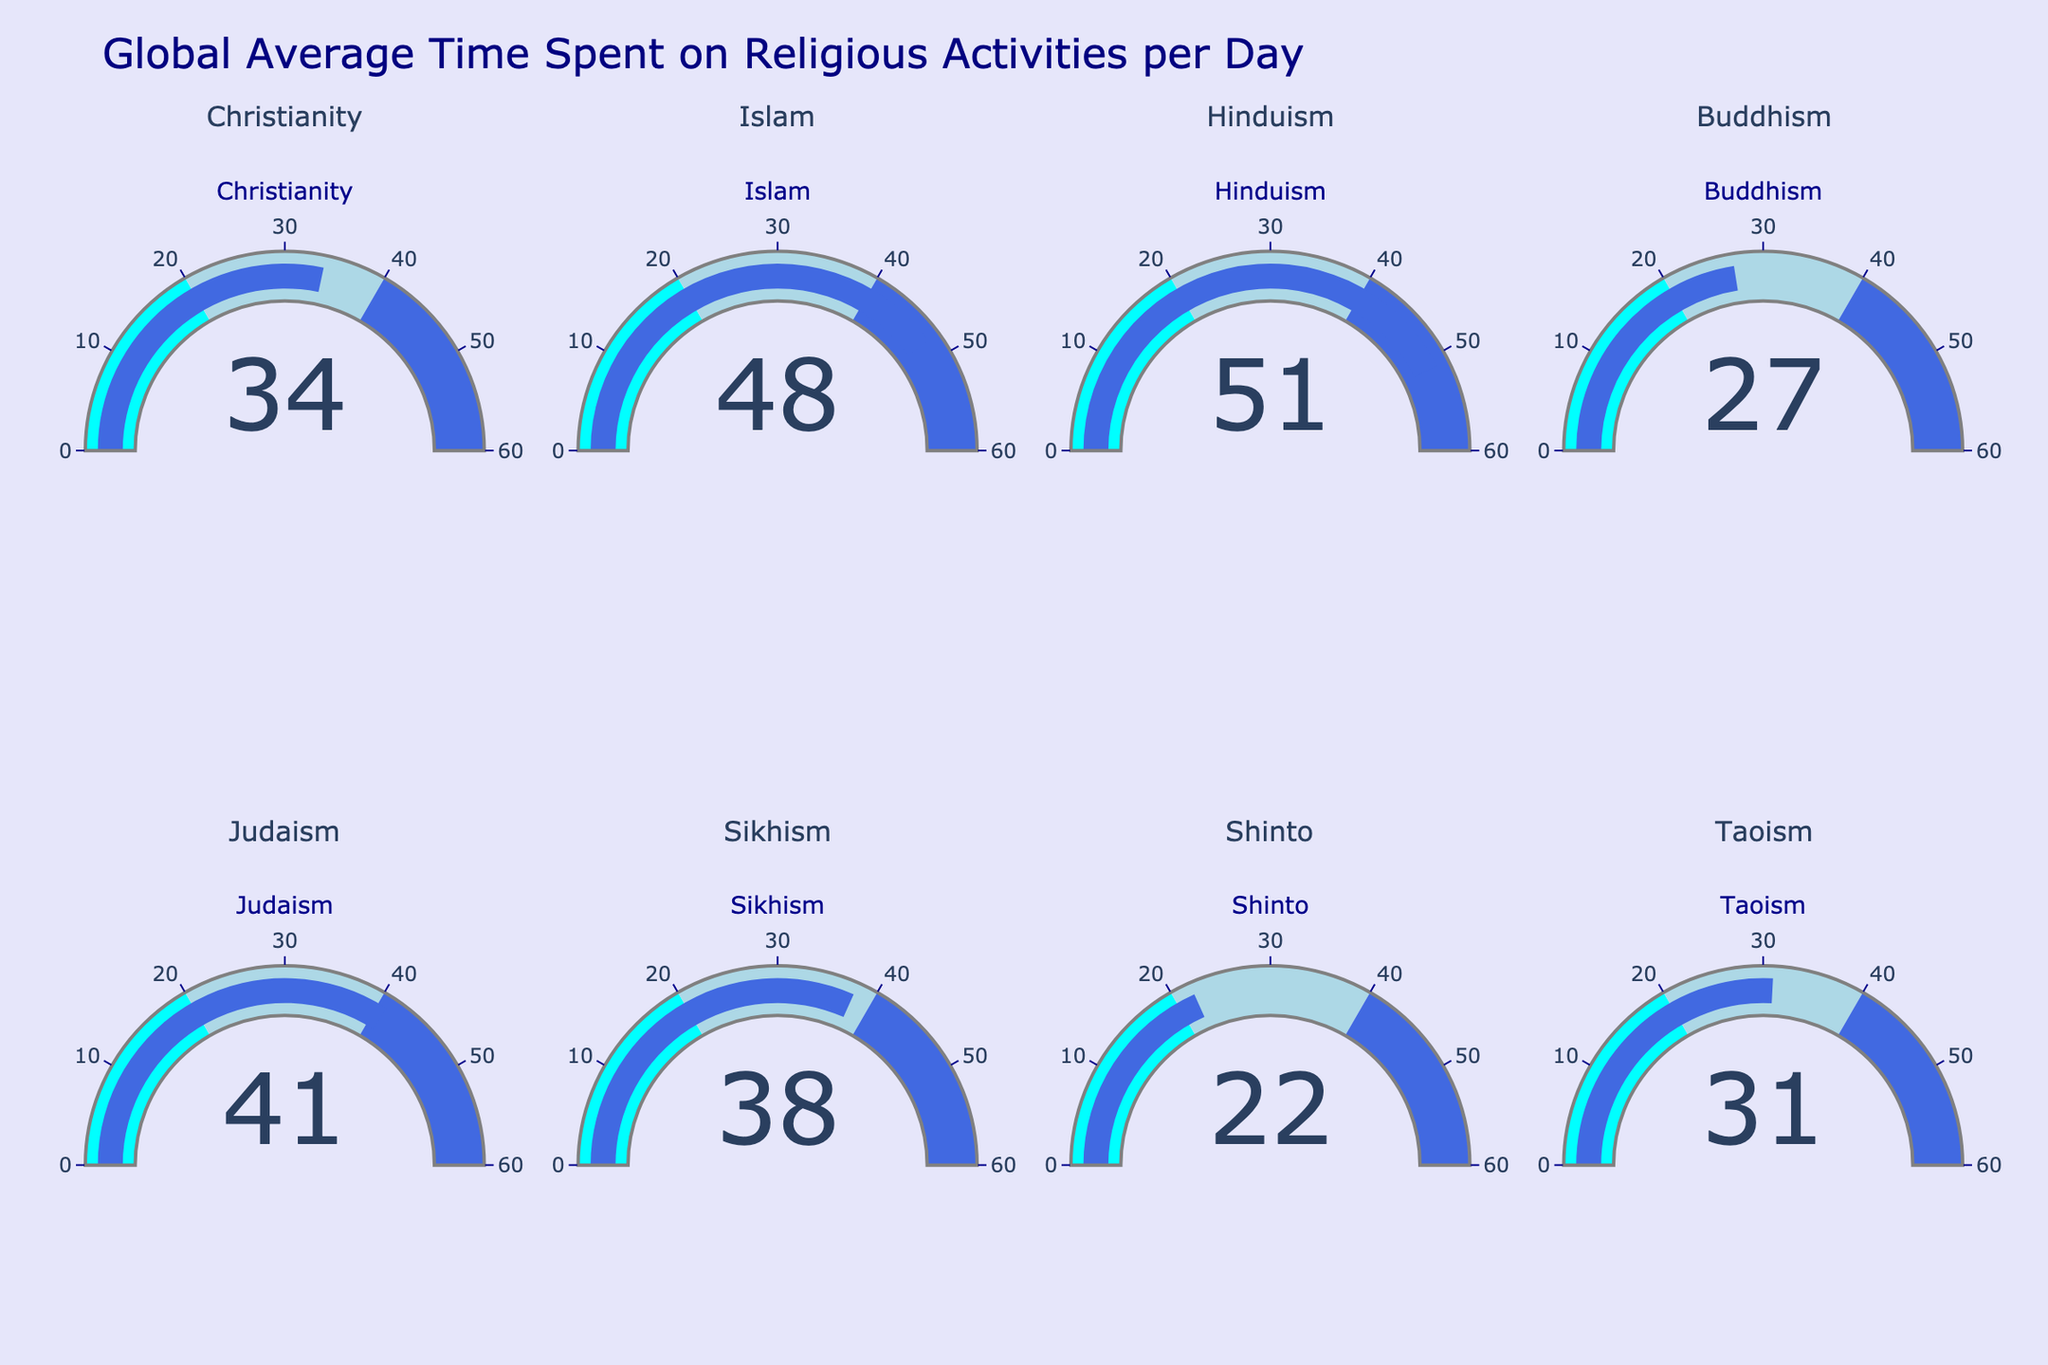What's the title of the chart? Look at the top of the chart where the main heading is displayed. The title encapsulates the overall theme of the chart.
Answer: Global Average Time Spent on Religious Activities per Day How many religions are represented in the chart? Count the number of gauge charts present, each representing a different religion.
Answer: Eight Which religion has the highest average time spent on religious activities per day? Compare the values displayed on each gauge chart. The one with the highest value is the answer.
Answer: Hinduism What's the difference in average time spent on religious activities between Buddhism and Judaism? Look at the gauge for Buddhism, which shows 27 minutes, and the gauge for Judaism, which shows 41 minutes. Compute the difference: 41 - 27.
Answer: 14 minutes Which religion spends more time on religious activities per day, Christianity or Sikhism? Compare the gauges for Christianity and Sikhism. Christianity shows 34 minutes, and Sikhism shows 38 minutes.
Answer: Sikhism What is the median time spent on religious activities among the listed religions? List all the times: 34, 48, 51, 27, 41, 38, 22, 31. Arrange them in ascending order: 22, 27, 31, 34, 38, 41, 48, 51. The median is the average of the middle two numbers: (34 + 38) / 2.
Answer: 36 minutes Which two religions have the closest average times spent on religious activities? Compare each pair of values to find the smallest difference.
Answer: Christianity and Taoism What's the average time spent on religious activities per day across all the religions in the chart? Sum all the values: 34 + 48 + 51 + 27 + 41 + 38 + 22 + 31 = 292. Divide by the number of religions (8).
Answer: 36.5 minutes 